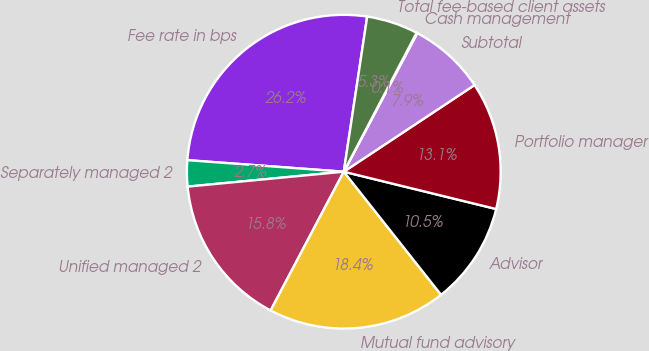Convert chart to OTSL. <chart><loc_0><loc_0><loc_500><loc_500><pie_chart><fcel>Fee rate in bps<fcel>Separately managed 2<fcel>Unified managed 2<fcel>Mutual fund advisory<fcel>Advisor<fcel>Portfolio manager<fcel>Subtotal<fcel>Cash management<fcel>Total fee-based client assets<nl><fcel>26.21%<fcel>2.69%<fcel>15.76%<fcel>18.37%<fcel>10.53%<fcel>13.14%<fcel>7.92%<fcel>0.08%<fcel>5.3%<nl></chart> 